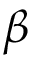<formula> <loc_0><loc_0><loc_500><loc_500>\beta</formula> 